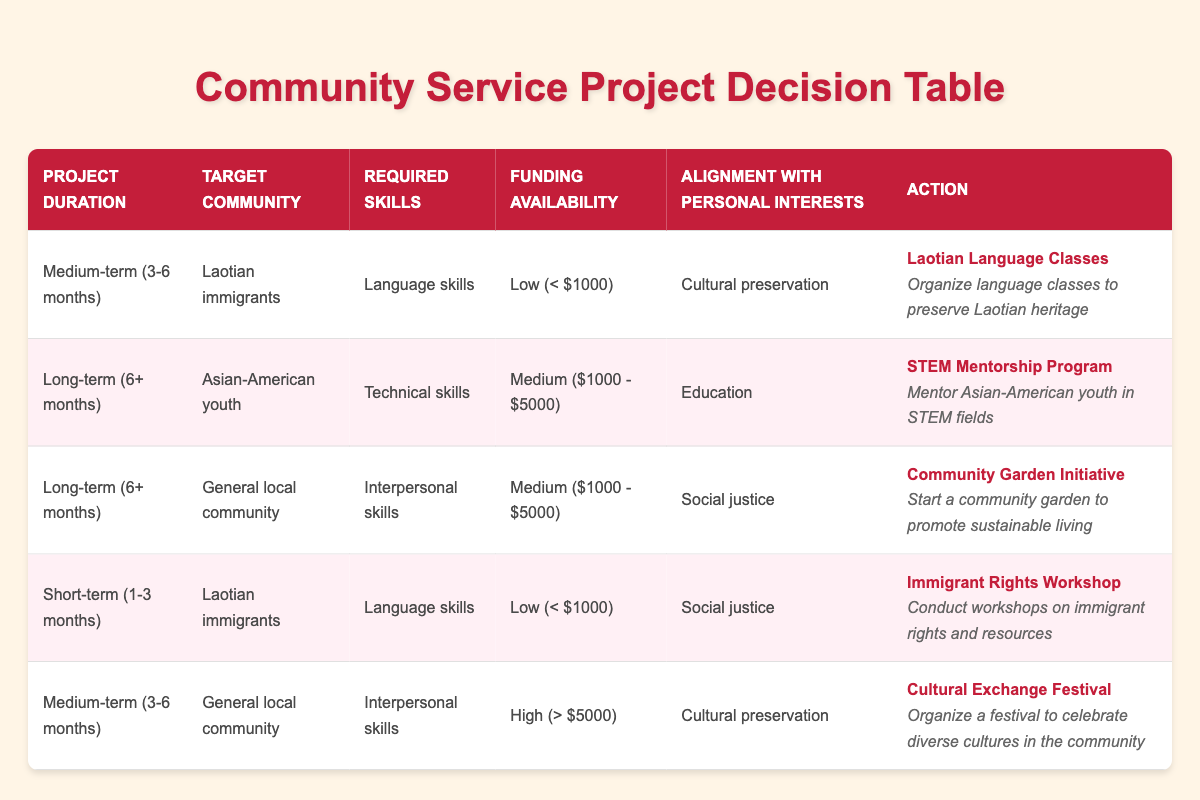What community service project is focused on cultural preservation and requires language skills for Laotian immigrants? The table shows that the "Laotian Language Classes" project is specifically aimed at "Laotian immigrants," focuses on "Cultural preservation," and requires "Language skills."
Answer: Laotian Language Classes Is there a community service project that targets Asian-American youth and has a funding availability of medium? Yes, the "STEM Mentorship Program" targets "Asian-American youth" and has "Medium ($1000 - $5000)" funding availability.
Answer: Yes What is the required skill for the "Community Garden Initiative"? According to the table, the "Community Garden Initiative" requires "Interpersonal skills" to start a garden for the general local community.
Answer: Interpersonal skills How many different projects are associated with Laotian immigrants? By examining the table, two projects are associated with "Laotian immigrants": "Laotian Language Classes" and "Immigrant Rights Workshop." Therefore, the total is 2.
Answer: 2 Which project has the highest funding availability and promotes cultural preservation? The "Cultural Exchange Festival" is indicated with "High (> $5000)" funding availability and focuses on "Cultural preservation" across the general local community.
Answer: Cultural Exchange Festival Are there any projects aimed at the general local community that require technical skills? No, the table does not list any project targeting the general local community that requires "Technical skills." The only project aimed at this community with required skills is "Interpersonal skills."
Answer: No What is the average duration for projects that cater to Laotian immigrants? The "Laotian Language Classes" project has a medium-term duration of 3-6 months and the "Immigrant Rights Workshop" has a short-term duration of 1-3 months. To find the average, we assign values (3.5 months for medium and 2 months for short) and calculate: (3.5 + 2) / 2 = 2.75 months.
Answer: 2.75 months How many projects are aligned with social justice interests? There are two projects aligned with "Social justice": "Immigrant Rights Workshop" and "Community Garden Initiative." Thus, the count is 2.
Answer: 2 What project lasts the longest while requiring technical skills and targeting Asian-American youth? The table indicates that the "STEM Mentorship Program" is a long-term project (6+ months), requiring "Technical skills," and specifically targets "Asian-American youth."
Answer: STEM Mentorship Program 